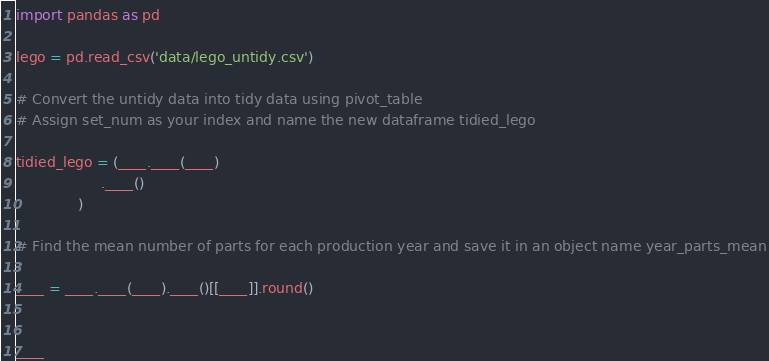<code> <loc_0><loc_0><loc_500><loc_500><_Python_>import pandas as pd

lego = pd.read_csv('data/lego_untidy.csv')

# Convert the untidy data into tidy data using pivot_table 
# Assign set_num as your index and name the new dataframe tidied_lego

tidied_lego = (____.____(____)
                   .____()
              )

# Find the mean number of parts for each production year and save it in an object name year_parts_mean

____ = ____.____(____).____()[[____]].round()


____
</code> 